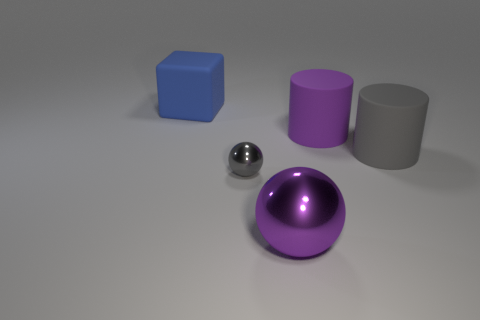There is a object in front of the metallic object left of the ball to the right of the gray shiny object; what is its color?
Provide a short and direct response. Purple. There is a big purple matte cylinder; are there any big rubber things behind it?
Your response must be concise. Yes. What size is the rubber cylinder that is the same color as the small thing?
Offer a terse response. Large. Is there a cylinder made of the same material as the block?
Offer a very short reply. Yes. The big ball is what color?
Ensure brevity in your answer.  Purple. There is a large matte object to the left of the large ball; is it the same shape as the tiny gray thing?
Give a very brief answer. No. There is a large rubber object on the left side of the large purple thing behind the large purple thing in front of the big gray cylinder; what shape is it?
Offer a very short reply. Cube. What is the material of the thing on the left side of the small gray shiny thing?
Offer a terse response. Rubber. What color is the shiny object that is the same size as the gray cylinder?
Ensure brevity in your answer.  Purple. How many other things are there of the same shape as the large purple metal thing?
Your answer should be compact. 1. 